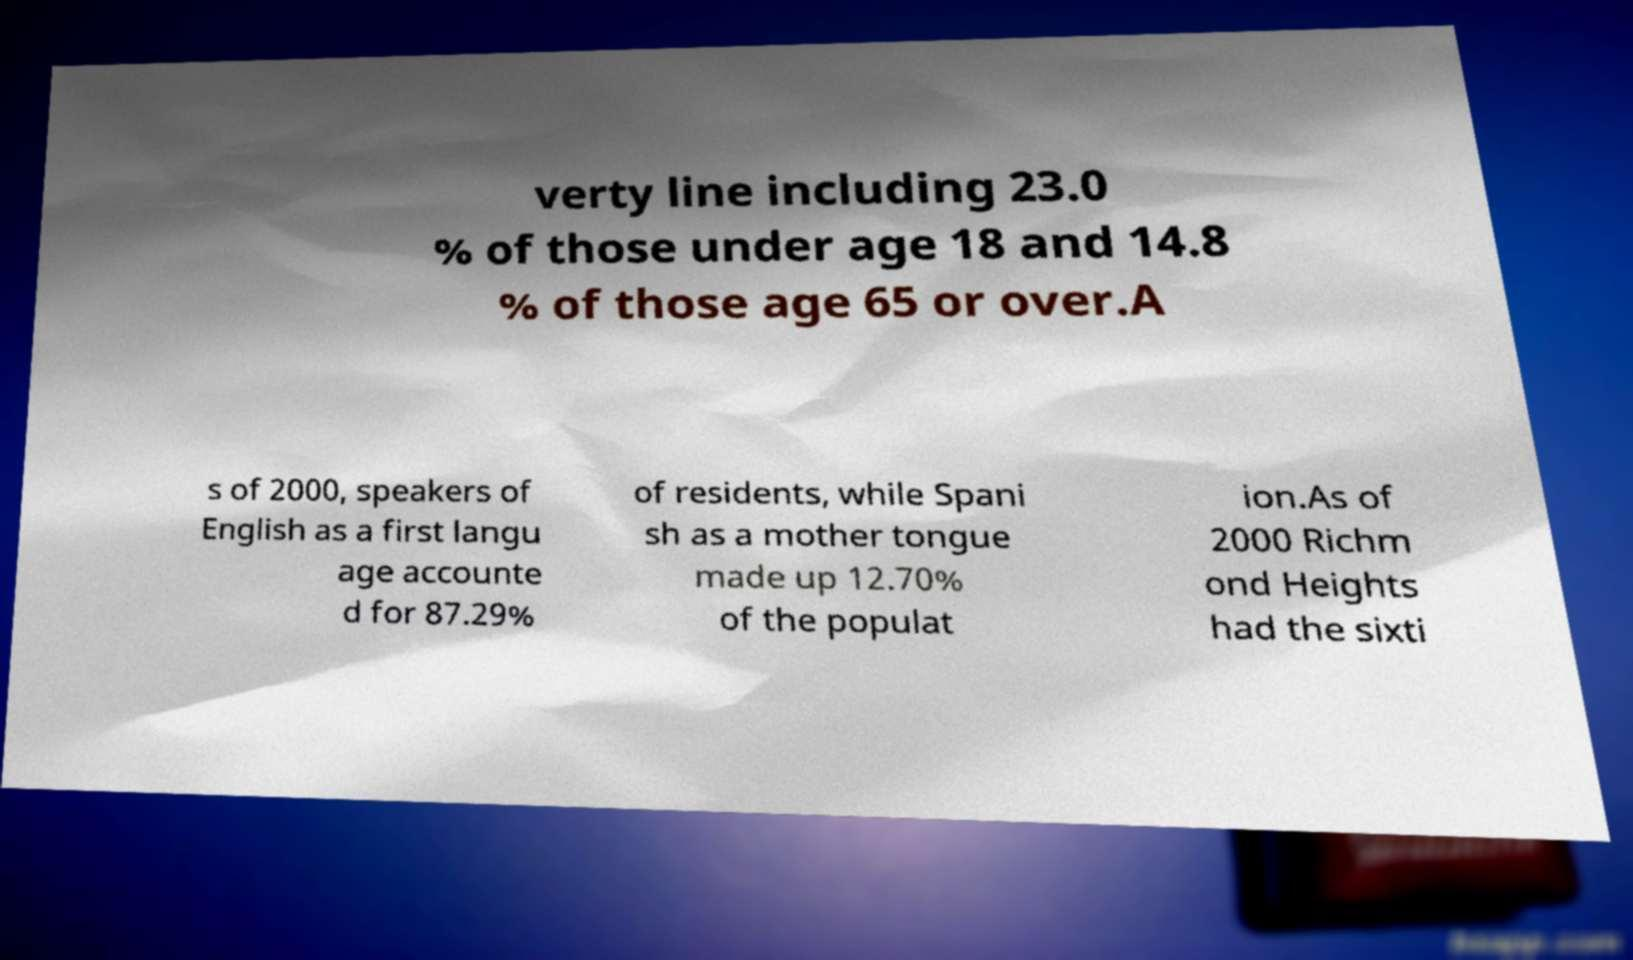Please identify and transcribe the text found in this image. verty line including 23.0 % of those under age 18 and 14.8 % of those age 65 or over.A s of 2000, speakers of English as a first langu age accounte d for 87.29% of residents, while Spani sh as a mother tongue made up 12.70% of the populat ion.As of 2000 Richm ond Heights had the sixti 